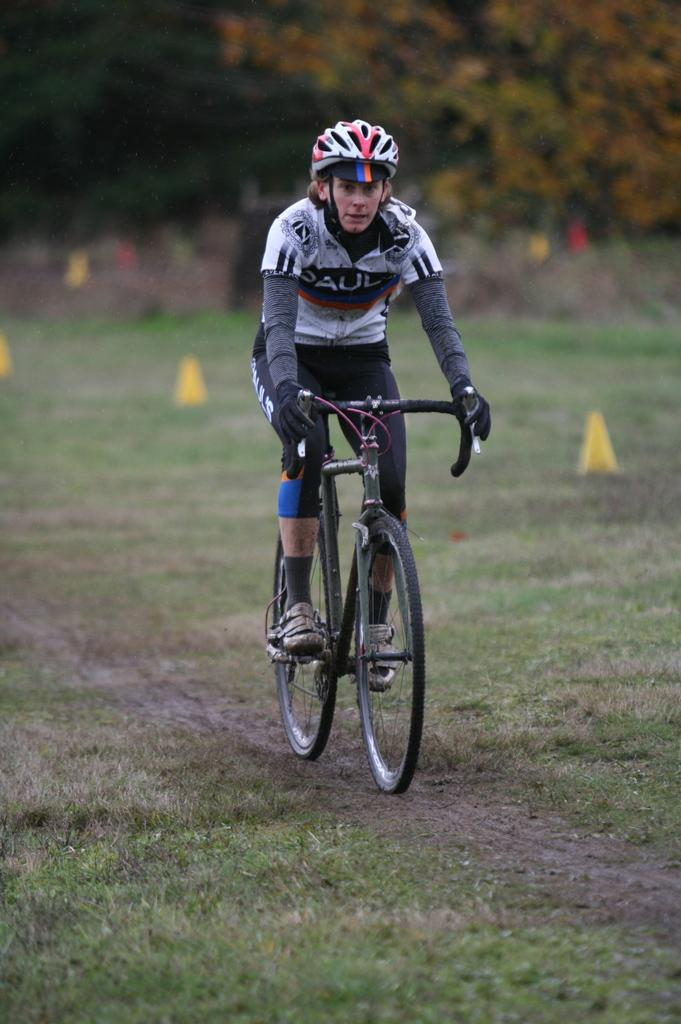Who is in the image? There is a man in the image. What is the man doing in the image? The man is sitting on a bicycle. What safety gear is the man wearing? The man is wearing a helmet. What type of terrain is visible in the image? The ground is covered with grass. How would you describe the background of the image? The background of the image is slightly blurry. Can you see any fans in the image? There are no fans visible in the image. What color are the man's eyes in the image? The man's eyes are not visible in the image, as he is wearing a helmet that covers his face. 